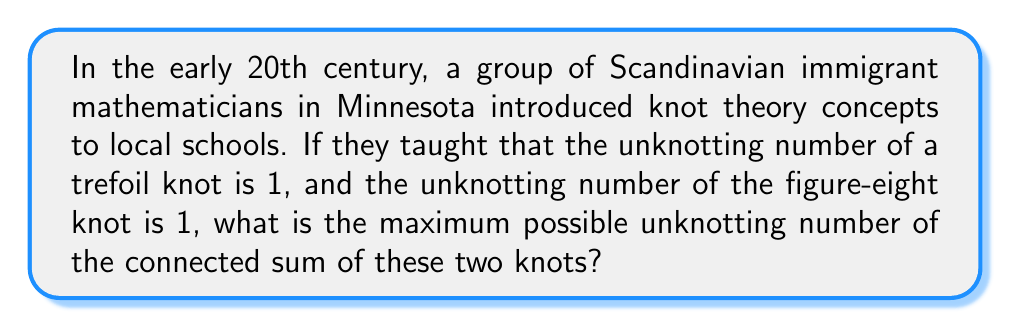What is the answer to this math problem? To solve this problem, we need to follow these steps:

1. Recall the definition of unknotting number:
   The unknotting number of a knot is the minimum number of crossings that need to be changed to transform the knot into the unknot.

2. Given information:
   - Unknotting number of trefoil knot: $U(T) = 1$
   - Unknotting number of figure-eight knot: $U(F) = 1$

3. Consider the connected sum of these knots:
   The connected sum of two knots $K_1$ and $K_2$ is denoted as $K_1 \# K_2$.

4. Apply the subadditivity property of unknotting numbers:
   For any two knots $K_1$ and $K_2$, we have:
   $$U(K_1 \# K_2) \leq U(K_1) + U(K_2)$$

5. Calculate the upper bound:
   $$U(T \# F) \leq U(T) + U(F) = 1 + 1 = 2$$

6. Conclusion:
   The maximum possible unknotting number of the connected sum is 2.

This problem illustrates how Scandinavian immigrants might have introduced advanced knot theory concepts to Minnesota's mathematical education, combining historical context with mathematical reasoning.
Answer: 2 